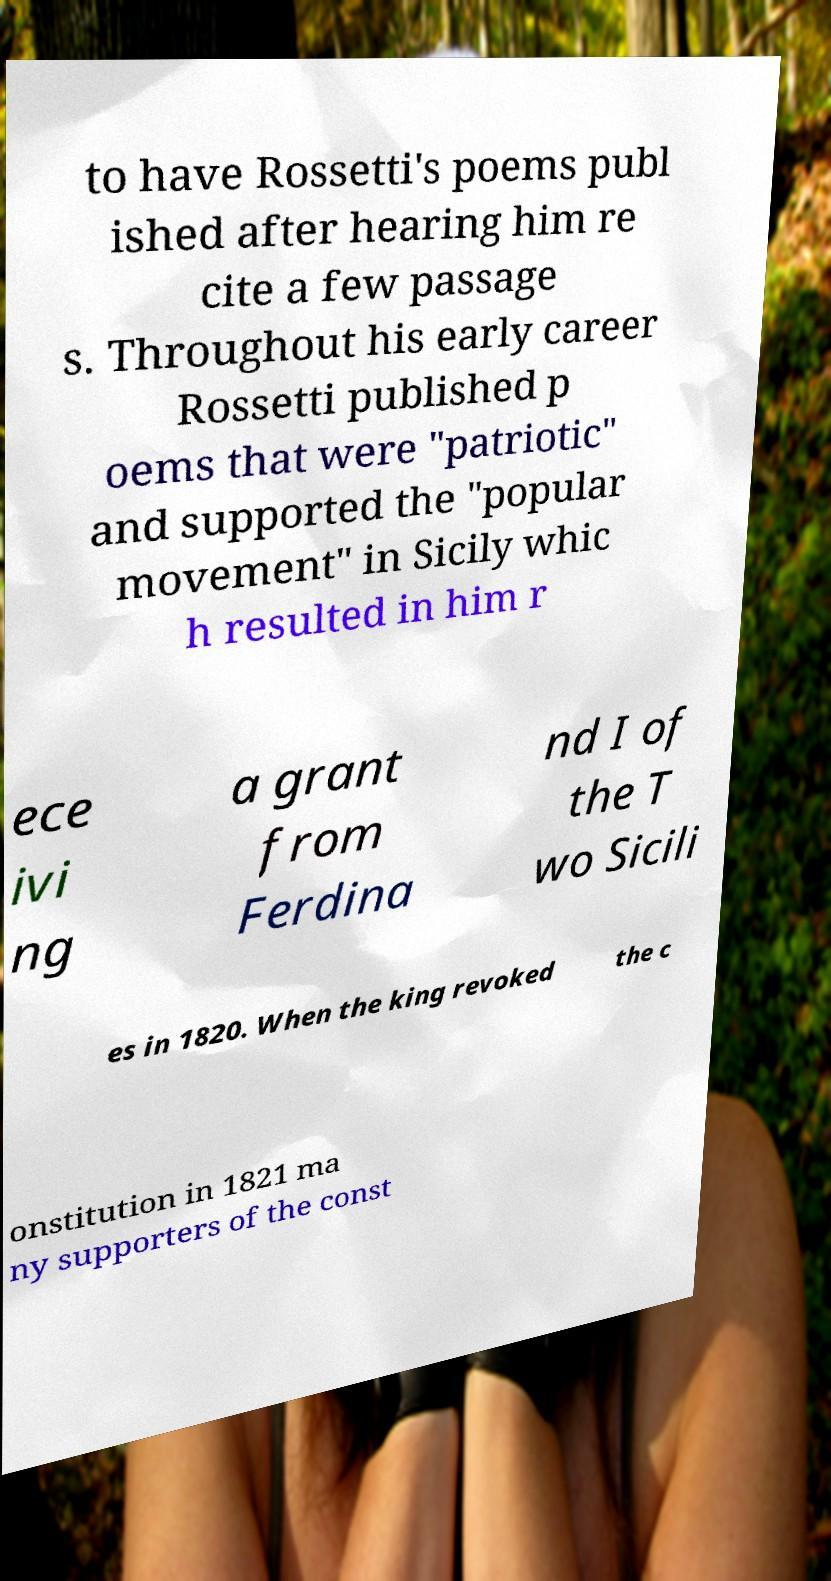There's text embedded in this image that I need extracted. Can you transcribe it verbatim? to have Rossetti's poems publ ished after hearing him re cite a few passage s. Throughout his early career Rossetti published p oems that were "patriotic" and supported the "popular movement" in Sicily whic h resulted in him r ece ivi ng a grant from Ferdina nd I of the T wo Sicili es in 1820. When the king revoked the c onstitution in 1821 ma ny supporters of the const 